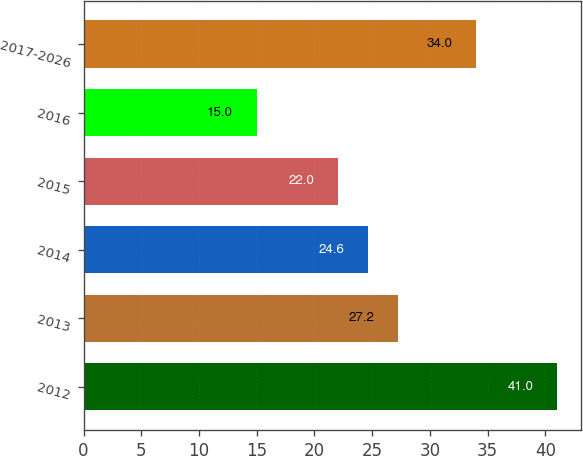Convert chart. <chart><loc_0><loc_0><loc_500><loc_500><bar_chart><fcel>2012<fcel>2013<fcel>2014<fcel>2015<fcel>2016<fcel>2017-2026<nl><fcel>41<fcel>27.2<fcel>24.6<fcel>22<fcel>15<fcel>34<nl></chart> 